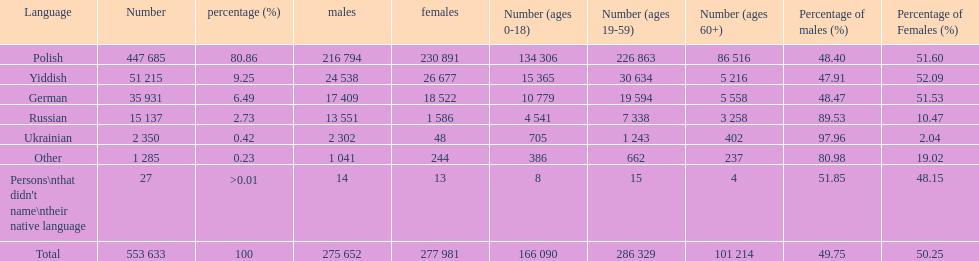Parse the full table. {'header': ['Language', 'Number', 'percentage (%)', 'males', 'females', 'Number (ages 0-18)', 'Number (ages 19-59)', 'Number (ages 60+)', 'Percentage of males (%)', 'Percentage of Females (%)'], 'rows': [['Polish', '447 685', '80.86', '216 794', '230 891', '134 306', '226 863', '86 516', '48.40', '51.60'], ['Yiddish', '51 215', '9.25', '24 538', '26 677', '15 365', '30 634', '5 216', '47.91', '52.09'], ['German', '35 931', '6.49', '17 409', '18 522', '10 779', '19 594', '5 558', '48.47', '51.53'], ['Russian', '15 137', '2.73', '13 551', '1 586', '4 541', '7 338', '3 258', '89.53', '10.47'], ['Ukrainian', '2 350', '0.42', '2 302', '48', '705', '1 243', '402', '97.96', '2.04'], ['Other', '1 285', '0.23', '1 041', '244', '386', '662', '237', '80.98', '19.02'], ["Persons\\nthat didn't name\\ntheir native language", '27', '>0.01', '14', '13', '8', '15', '4', '51.85', '48.15'], ['Total', '553 633', '100', '275 652', '277 981', '166 090', '286 329', '101 214', '49.75', '50.25']]} How many people didn't name their native language? 27. 